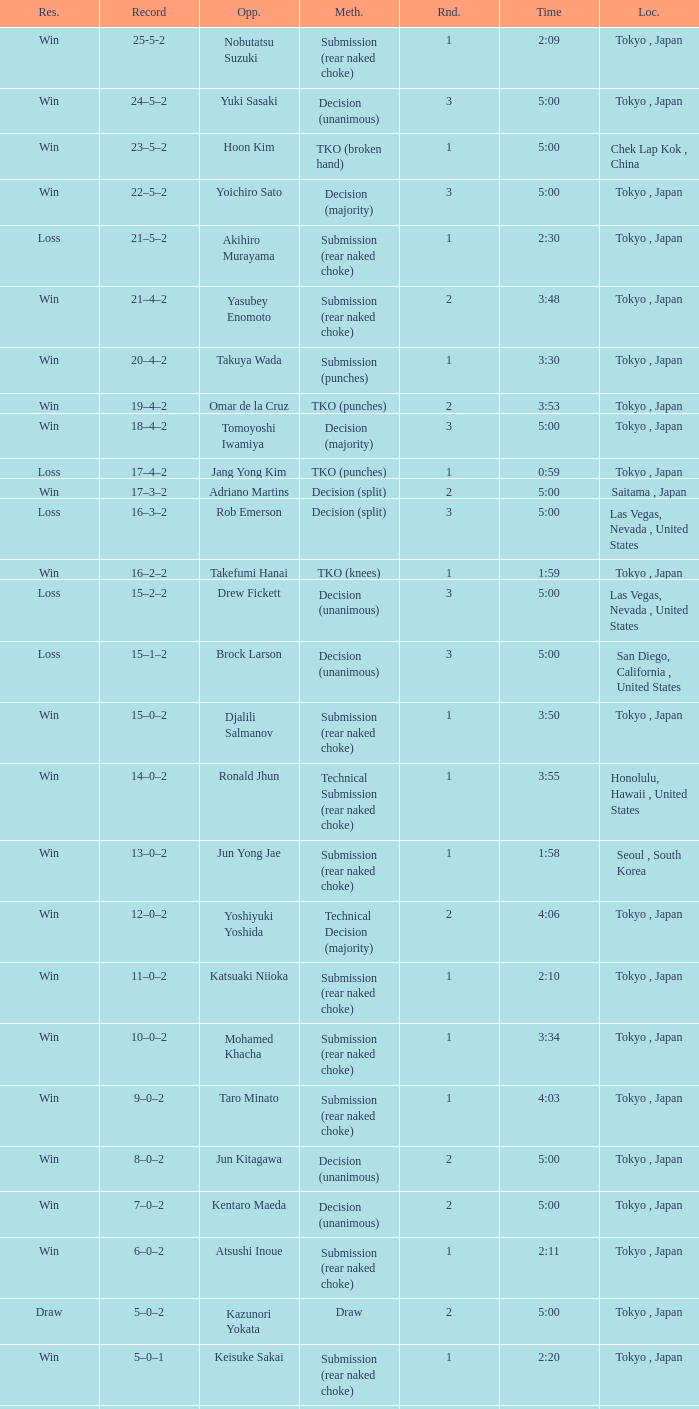What method had Adriano Martins as an opponent and a time of 5:00? Decision (split). 